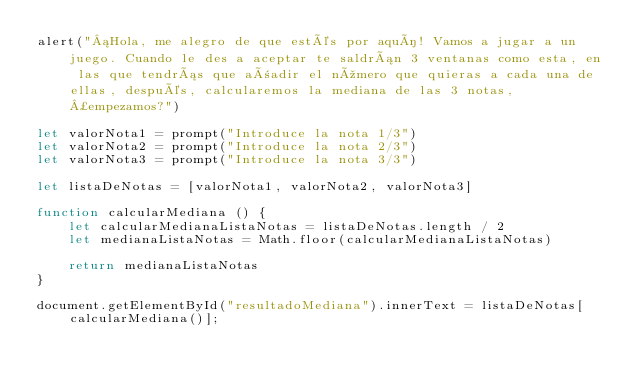Convert code to text. <code><loc_0><loc_0><loc_500><loc_500><_JavaScript_>alert("¡Hola, me alegro de que estés por aquí! Vamos a jugar a un juego. Cuando le des a aceptar te saldrán 3 ventanas como esta, en las que tendrás que añadir el número que quieras a cada una de ellas, después, calcularemos la mediana de las 3 notas, ¿empezamos?")

let valorNota1 = prompt("Introduce la nota 1/3")
let valorNota2 = prompt("Introduce la nota 2/3")
let valorNota3 = prompt("Introduce la nota 3/3")

let listaDeNotas = [valorNota1, valorNota2, valorNota3]

function calcularMediana () {
    let calcularMedianaListaNotas = listaDeNotas.length / 2
    let medianaListaNotas = Math.floor(calcularMedianaListaNotas)

    return medianaListaNotas
}

document.getElementById("resultadoMediana").innerText = listaDeNotas[calcularMediana()];</code> 